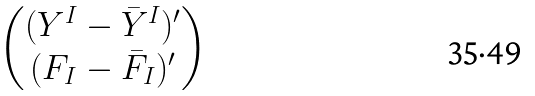<formula> <loc_0><loc_0><loc_500><loc_500>\begin{pmatrix} ( Y ^ { I } - { \bar { Y } } ^ { I } ) ^ { \prime } \\ ( F _ { I } - { \bar { F } } _ { I } ) ^ { \prime } \end{pmatrix}</formula> 